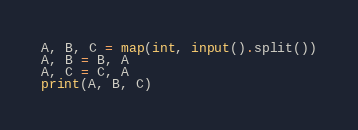Convert code to text. <code><loc_0><loc_0><loc_500><loc_500><_Python_>A, B, C = map(int, input().split())
A, B = B, A
A, C = C, A
print(A, B, C)</code> 